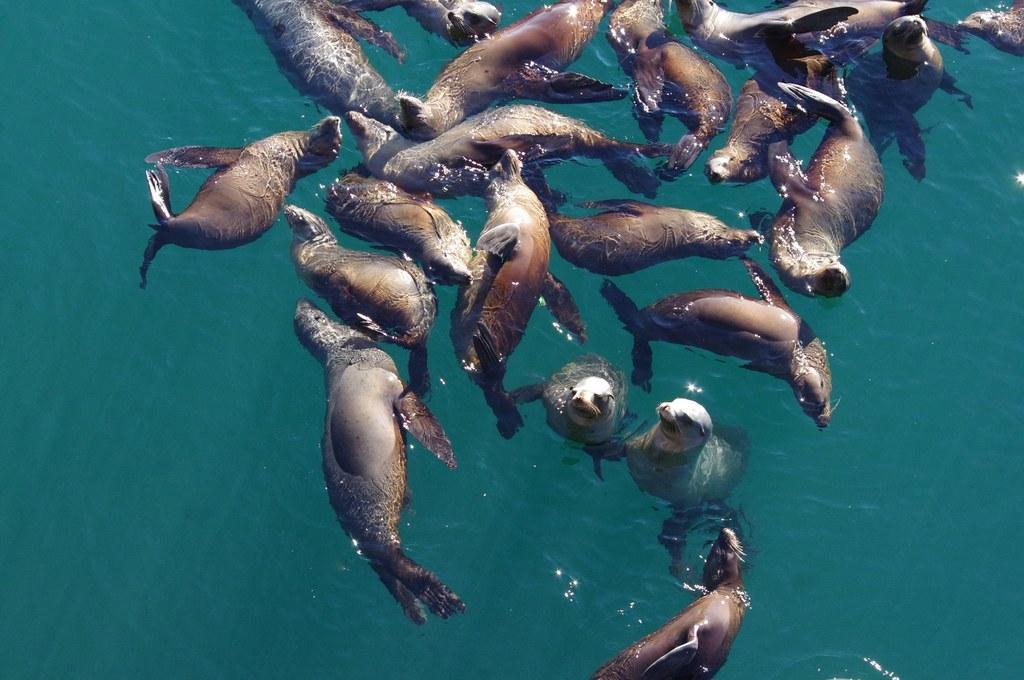How would you summarize this image in a sentence or two? In this image we can see sea lions in the water. 